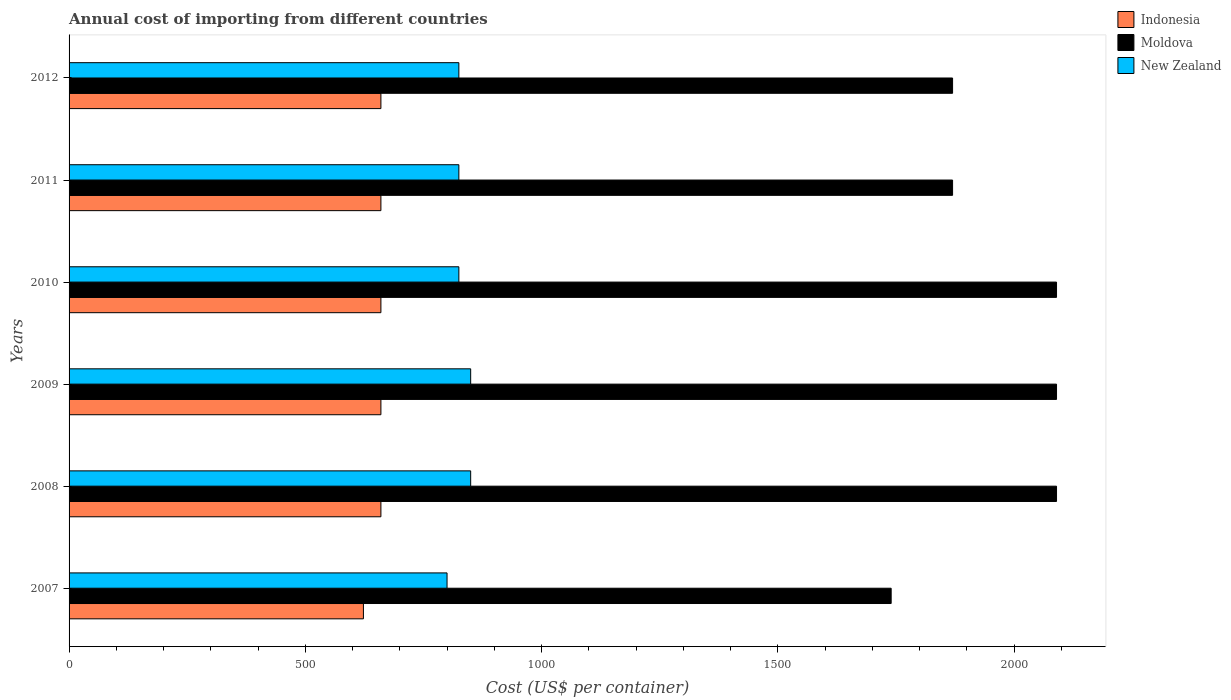How many different coloured bars are there?
Give a very brief answer. 3. How many bars are there on the 1st tick from the top?
Keep it short and to the point. 3. In how many cases, is the number of bars for a given year not equal to the number of legend labels?
Your answer should be compact. 0. What is the total annual cost of importing in New Zealand in 2007?
Offer a very short reply. 800. Across all years, what is the maximum total annual cost of importing in Moldova?
Your response must be concise. 2090. Across all years, what is the minimum total annual cost of importing in New Zealand?
Your answer should be very brief. 800. In which year was the total annual cost of importing in Moldova minimum?
Keep it short and to the point. 2007. What is the total total annual cost of importing in New Zealand in the graph?
Provide a short and direct response. 4975. What is the difference between the total annual cost of importing in New Zealand in 2008 and that in 2012?
Provide a short and direct response. 25. What is the difference between the total annual cost of importing in Indonesia in 2009 and the total annual cost of importing in Moldova in 2007?
Offer a terse response. -1080. What is the average total annual cost of importing in New Zealand per year?
Your answer should be compact. 829.17. In the year 2011, what is the difference between the total annual cost of importing in Indonesia and total annual cost of importing in New Zealand?
Provide a succinct answer. -165. What is the ratio of the total annual cost of importing in Moldova in 2010 to that in 2012?
Your answer should be compact. 1.12. What is the difference between the highest and the second highest total annual cost of importing in New Zealand?
Provide a succinct answer. 0. What is the difference between the highest and the lowest total annual cost of importing in New Zealand?
Provide a short and direct response. 50. Is the sum of the total annual cost of importing in New Zealand in 2007 and 2009 greater than the maximum total annual cost of importing in Indonesia across all years?
Keep it short and to the point. Yes. What does the 2nd bar from the top in 2010 represents?
Offer a very short reply. Moldova. What does the 3rd bar from the bottom in 2009 represents?
Offer a terse response. New Zealand. Is it the case that in every year, the sum of the total annual cost of importing in New Zealand and total annual cost of importing in Indonesia is greater than the total annual cost of importing in Moldova?
Provide a succinct answer. No. How many bars are there?
Your answer should be very brief. 18. What is the difference between two consecutive major ticks on the X-axis?
Keep it short and to the point. 500. Are the values on the major ticks of X-axis written in scientific E-notation?
Provide a succinct answer. No. Does the graph contain any zero values?
Offer a terse response. No. Where does the legend appear in the graph?
Provide a short and direct response. Top right. How are the legend labels stacked?
Offer a terse response. Vertical. What is the title of the graph?
Offer a very short reply. Annual cost of importing from different countries. What is the label or title of the X-axis?
Offer a terse response. Cost (US$ per container). What is the Cost (US$ per container) of Indonesia in 2007?
Your answer should be very brief. 623. What is the Cost (US$ per container) in Moldova in 2007?
Make the answer very short. 1740. What is the Cost (US$ per container) of New Zealand in 2007?
Your answer should be very brief. 800. What is the Cost (US$ per container) in Indonesia in 2008?
Your answer should be compact. 660. What is the Cost (US$ per container) in Moldova in 2008?
Offer a very short reply. 2090. What is the Cost (US$ per container) in New Zealand in 2008?
Make the answer very short. 850. What is the Cost (US$ per container) in Indonesia in 2009?
Ensure brevity in your answer.  660. What is the Cost (US$ per container) of Moldova in 2009?
Provide a succinct answer. 2090. What is the Cost (US$ per container) in New Zealand in 2009?
Ensure brevity in your answer.  850. What is the Cost (US$ per container) in Indonesia in 2010?
Give a very brief answer. 660. What is the Cost (US$ per container) of Moldova in 2010?
Keep it short and to the point. 2090. What is the Cost (US$ per container) in New Zealand in 2010?
Keep it short and to the point. 825. What is the Cost (US$ per container) of Indonesia in 2011?
Ensure brevity in your answer.  660. What is the Cost (US$ per container) of Moldova in 2011?
Give a very brief answer. 1870. What is the Cost (US$ per container) of New Zealand in 2011?
Offer a very short reply. 825. What is the Cost (US$ per container) in Indonesia in 2012?
Your response must be concise. 660. What is the Cost (US$ per container) of Moldova in 2012?
Your response must be concise. 1870. What is the Cost (US$ per container) in New Zealand in 2012?
Offer a very short reply. 825. Across all years, what is the maximum Cost (US$ per container) of Indonesia?
Offer a very short reply. 660. Across all years, what is the maximum Cost (US$ per container) of Moldova?
Make the answer very short. 2090. Across all years, what is the maximum Cost (US$ per container) of New Zealand?
Provide a short and direct response. 850. Across all years, what is the minimum Cost (US$ per container) of Indonesia?
Keep it short and to the point. 623. Across all years, what is the minimum Cost (US$ per container) of Moldova?
Provide a succinct answer. 1740. Across all years, what is the minimum Cost (US$ per container) in New Zealand?
Offer a very short reply. 800. What is the total Cost (US$ per container) in Indonesia in the graph?
Your answer should be compact. 3923. What is the total Cost (US$ per container) in Moldova in the graph?
Offer a very short reply. 1.18e+04. What is the total Cost (US$ per container) in New Zealand in the graph?
Your response must be concise. 4975. What is the difference between the Cost (US$ per container) in Indonesia in 2007 and that in 2008?
Offer a terse response. -37. What is the difference between the Cost (US$ per container) of Moldova in 2007 and that in 2008?
Keep it short and to the point. -350. What is the difference between the Cost (US$ per container) in New Zealand in 2007 and that in 2008?
Your answer should be very brief. -50. What is the difference between the Cost (US$ per container) in Indonesia in 2007 and that in 2009?
Give a very brief answer. -37. What is the difference between the Cost (US$ per container) of Moldova in 2007 and that in 2009?
Your response must be concise. -350. What is the difference between the Cost (US$ per container) of Indonesia in 2007 and that in 2010?
Keep it short and to the point. -37. What is the difference between the Cost (US$ per container) in Moldova in 2007 and that in 2010?
Your response must be concise. -350. What is the difference between the Cost (US$ per container) in Indonesia in 2007 and that in 2011?
Make the answer very short. -37. What is the difference between the Cost (US$ per container) of Moldova in 2007 and that in 2011?
Your answer should be very brief. -130. What is the difference between the Cost (US$ per container) in Indonesia in 2007 and that in 2012?
Offer a very short reply. -37. What is the difference between the Cost (US$ per container) of Moldova in 2007 and that in 2012?
Offer a very short reply. -130. What is the difference between the Cost (US$ per container) in New Zealand in 2007 and that in 2012?
Make the answer very short. -25. What is the difference between the Cost (US$ per container) in Moldova in 2008 and that in 2009?
Keep it short and to the point. 0. What is the difference between the Cost (US$ per container) in Indonesia in 2008 and that in 2010?
Make the answer very short. 0. What is the difference between the Cost (US$ per container) in Moldova in 2008 and that in 2010?
Give a very brief answer. 0. What is the difference between the Cost (US$ per container) in Moldova in 2008 and that in 2011?
Offer a terse response. 220. What is the difference between the Cost (US$ per container) of New Zealand in 2008 and that in 2011?
Give a very brief answer. 25. What is the difference between the Cost (US$ per container) in Moldova in 2008 and that in 2012?
Give a very brief answer. 220. What is the difference between the Cost (US$ per container) in New Zealand in 2008 and that in 2012?
Your answer should be compact. 25. What is the difference between the Cost (US$ per container) of Indonesia in 2009 and that in 2010?
Provide a short and direct response. 0. What is the difference between the Cost (US$ per container) of New Zealand in 2009 and that in 2010?
Make the answer very short. 25. What is the difference between the Cost (US$ per container) in Indonesia in 2009 and that in 2011?
Your answer should be very brief. 0. What is the difference between the Cost (US$ per container) in Moldova in 2009 and that in 2011?
Provide a short and direct response. 220. What is the difference between the Cost (US$ per container) in Indonesia in 2009 and that in 2012?
Keep it short and to the point. 0. What is the difference between the Cost (US$ per container) of Moldova in 2009 and that in 2012?
Make the answer very short. 220. What is the difference between the Cost (US$ per container) in Moldova in 2010 and that in 2011?
Offer a very short reply. 220. What is the difference between the Cost (US$ per container) of New Zealand in 2010 and that in 2011?
Your answer should be compact. 0. What is the difference between the Cost (US$ per container) in Moldova in 2010 and that in 2012?
Your response must be concise. 220. What is the difference between the Cost (US$ per container) of Moldova in 2011 and that in 2012?
Your response must be concise. 0. What is the difference between the Cost (US$ per container) of New Zealand in 2011 and that in 2012?
Provide a succinct answer. 0. What is the difference between the Cost (US$ per container) in Indonesia in 2007 and the Cost (US$ per container) in Moldova in 2008?
Offer a very short reply. -1467. What is the difference between the Cost (US$ per container) of Indonesia in 2007 and the Cost (US$ per container) of New Zealand in 2008?
Your answer should be very brief. -227. What is the difference between the Cost (US$ per container) in Moldova in 2007 and the Cost (US$ per container) in New Zealand in 2008?
Your answer should be compact. 890. What is the difference between the Cost (US$ per container) of Indonesia in 2007 and the Cost (US$ per container) of Moldova in 2009?
Your answer should be very brief. -1467. What is the difference between the Cost (US$ per container) in Indonesia in 2007 and the Cost (US$ per container) in New Zealand in 2009?
Your response must be concise. -227. What is the difference between the Cost (US$ per container) of Moldova in 2007 and the Cost (US$ per container) of New Zealand in 2009?
Offer a terse response. 890. What is the difference between the Cost (US$ per container) of Indonesia in 2007 and the Cost (US$ per container) of Moldova in 2010?
Keep it short and to the point. -1467. What is the difference between the Cost (US$ per container) of Indonesia in 2007 and the Cost (US$ per container) of New Zealand in 2010?
Provide a short and direct response. -202. What is the difference between the Cost (US$ per container) in Moldova in 2007 and the Cost (US$ per container) in New Zealand in 2010?
Provide a short and direct response. 915. What is the difference between the Cost (US$ per container) in Indonesia in 2007 and the Cost (US$ per container) in Moldova in 2011?
Give a very brief answer. -1247. What is the difference between the Cost (US$ per container) in Indonesia in 2007 and the Cost (US$ per container) in New Zealand in 2011?
Offer a very short reply. -202. What is the difference between the Cost (US$ per container) in Moldova in 2007 and the Cost (US$ per container) in New Zealand in 2011?
Offer a terse response. 915. What is the difference between the Cost (US$ per container) of Indonesia in 2007 and the Cost (US$ per container) of Moldova in 2012?
Make the answer very short. -1247. What is the difference between the Cost (US$ per container) in Indonesia in 2007 and the Cost (US$ per container) in New Zealand in 2012?
Your response must be concise. -202. What is the difference between the Cost (US$ per container) of Moldova in 2007 and the Cost (US$ per container) of New Zealand in 2012?
Provide a short and direct response. 915. What is the difference between the Cost (US$ per container) of Indonesia in 2008 and the Cost (US$ per container) of Moldova in 2009?
Provide a short and direct response. -1430. What is the difference between the Cost (US$ per container) of Indonesia in 2008 and the Cost (US$ per container) of New Zealand in 2009?
Your answer should be compact. -190. What is the difference between the Cost (US$ per container) of Moldova in 2008 and the Cost (US$ per container) of New Zealand in 2009?
Offer a very short reply. 1240. What is the difference between the Cost (US$ per container) of Indonesia in 2008 and the Cost (US$ per container) of Moldova in 2010?
Provide a succinct answer. -1430. What is the difference between the Cost (US$ per container) of Indonesia in 2008 and the Cost (US$ per container) of New Zealand in 2010?
Your answer should be very brief. -165. What is the difference between the Cost (US$ per container) in Moldova in 2008 and the Cost (US$ per container) in New Zealand in 2010?
Provide a short and direct response. 1265. What is the difference between the Cost (US$ per container) in Indonesia in 2008 and the Cost (US$ per container) in Moldova in 2011?
Give a very brief answer. -1210. What is the difference between the Cost (US$ per container) in Indonesia in 2008 and the Cost (US$ per container) in New Zealand in 2011?
Offer a terse response. -165. What is the difference between the Cost (US$ per container) in Moldova in 2008 and the Cost (US$ per container) in New Zealand in 2011?
Provide a succinct answer. 1265. What is the difference between the Cost (US$ per container) in Indonesia in 2008 and the Cost (US$ per container) in Moldova in 2012?
Ensure brevity in your answer.  -1210. What is the difference between the Cost (US$ per container) in Indonesia in 2008 and the Cost (US$ per container) in New Zealand in 2012?
Provide a succinct answer. -165. What is the difference between the Cost (US$ per container) of Moldova in 2008 and the Cost (US$ per container) of New Zealand in 2012?
Your answer should be compact. 1265. What is the difference between the Cost (US$ per container) of Indonesia in 2009 and the Cost (US$ per container) of Moldova in 2010?
Make the answer very short. -1430. What is the difference between the Cost (US$ per container) of Indonesia in 2009 and the Cost (US$ per container) of New Zealand in 2010?
Your answer should be compact. -165. What is the difference between the Cost (US$ per container) of Moldova in 2009 and the Cost (US$ per container) of New Zealand in 2010?
Provide a succinct answer. 1265. What is the difference between the Cost (US$ per container) in Indonesia in 2009 and the Cost (US$ per container) in Moldova in 2011?
Make the answer very short. -1210. What is the difference between the Cost (US$ per container) of Indonesia in 2009 and the Cost (US$ per container) of New Zealand in 2011?
Your response must be concise. -165. What is the difference between the Cost (US$ per container) of Moldova in 2009 and the Cost (US$ per container) of New Zealand in 2011?
Keep it short and to the point. 1265. What is the difference between the Cost (US$ per container) in Indonesia in 2009 and the Cost (US$ per container) in Moldova in 2012?
Ensure brevity in your answer.  -1210. What is the difference between the Cost (US$ per container) of Indonesia in 2009 and the Cost (US$ per container) of New Zealand in 2012?
Offer a very short reply. -165. What is the difference between the Cost (US$ per container) of Moldova in 2009 and the Cost (US$ per container) of New Zealand in 2012?
Provide a succinct answer. 1265. What is the difference between the Cost (US$ per container) in Indonesia in 2010 and the Cost (US$ per container) in Moldova in 2011?
Your response must be concise. -1210. What is the difference between the Cost (US$ per container) in Indonesia in 2010 and the Cost (US$ per container) in New Zealand in 2011?
Provide a short and direct response. -165. What is the difference between the Cost (US$ per container) of Moldova in 2010 and the Cost (US$ per container) of New Zealand in 2011?
Offer a terse response. 1265. What is the difference between the Cost (US$ per container) of Indonesia in 2010 and the Cost (US$ per container) of Moldova in 2012?
Make the answer very short. -1210. What is the difference between the Cost (US$ per container) of Indonesia in 2010 and the Cost (US$ per container) of New Zealand in 2012?
Offer a very short reply. -165. What is the difference between the Cost (US$ per container) in Moldova in 2010 and the Cost (US$ per container) in New Zealand in 2012?
Give a very brief answer. 1265. What is the difference between the Cost (US$ per container) of Indonesia in 2011 and the Cost (US$ per container) of Moldova in 2012?
Your answer should be compact. -1210. What is the difference between the Cost (US$ per container) in Indonesia in 2011 and the Cost (US$ per container) in New Zealand in 2012?
Ensure brevity in your answer.  -165. What is the difference between the Cost (US$ per container) in Moldova in 2011 and the Cost (US$ per container) in New Zealand in 2012?
Your answer should be very brief. 1045. What is the average Cost (US$ per container) in Indonesia per year?
Give a very brief answer. 653.83. What is the average Cost (US$ per container) of Moldova per year?
Offer a terse response. 1958.33. What is the average Cost (US$ per container) of New Zealand per year?
Make the answer very short. 829.17. In the year 2007, what is the difference between the Cost (US$ per container) in Indonesia and Cost (US$ per container) in Moldova?
Provide a succinct answer. -1117. In the year 2007, what is the difference between the Cost (US$ per container) of Indonesia and Cost (US$ per container) of New Zealand?
Your answer should be compact. -177. In the year 2007, what is the difference between the Cost (US$ per container) of Moldova and Cost (US$ per container) of New Zealand?
Your response must be concise. 940. In the year 2008, what is the difference between the Cost (US$ per container) in Indonesia and Cost (US$ per container) in Moldova?
Ensure brevity in your answer.  -1430. In the year 2008, what is the difference between the Cost (US$ per container) of Indonesia and Cost (US$ per container) of New Zealand?
Your answer should be compact. -190. In the year 2008, what is the difference between the Cost (US$ per container) in Moldova and Cost (US$ per container) in New Zealand?
Your answer should be very brief. 1240. In the year 2009, what is the difference between the Cost (US$ per container) in Indonesia and Cost (US$ per container) in Moldova?
Your response must be concise. -1430. In the year 2009, what is the difference between the Cost (US$ per container) in Indonesia and Cost (US$ per container) in New Zealand?
Keep it short and to the point. -190. In the year 2009, what is the difference between the Cost (US$ per container) in Moldova and Cost (US$ per container) in New Zealand?
Give a very brief answer. 1240. In the year 2010, what is the difference between the Cost (US$ per container) of Indonesia and Cost (US$ per container) of Moldova?
Give a very brief answer. -1430. In the year 2010, what is the difference between the Cost (US$ per container) in Indonesia and Cost (US$ per container) in New Zealand?
Your answer should be very brief. -165. In the year 2010, what is the difference between the Cost (US$ per container) of Moldova and Cost (US$ per container) of New Zealand?
Offer a terse response. 1265. In the year 2011, what is the difference between the Cost (US$ per container) of Indonesia and Cost (US$ per container) of Moldova?
Give a very brief answer. -1210. In the year 2011, what is the difference between the Cost (US$ per container) of Indonesia and Cost (US$ per container) of New Zealand?
Your answer should be compact. -165. In the year 2011, what is the difference between the Cost (US$ per container) of Moldova and Cost (US$ per container) of New Zealand?
Your response must be concise. 1045. In the year 2012, what is the difference between the Cost (US$ per container) of Indonesia and Cost (US$ per container) of Moldova?
Offer a very short reply. -1210. In the year 2012, what is the difference between the Cost (US$ per container) in Indonesia and Cost (US$ per container) in New Zealand?
Your answer should be compact. -165. In the year 2012, what is the difference between the Cost (US$ per container) in Moldova and Cost (US$ per container) in New Zealand?
Keep it short and to the point. 1045. What is the ratio of the Cost (US$ per container) of Indonesia in 2007 to that in 2008?
Provide a short and direct response. 0.94. What is the ratio of the Cost (US$ per container) in Moldova in 2007 to that in 2008?
Your answer should be very brief. 0.83. What is the ratio of the Cost (US$ per container) of New Zealand in 2007 to that in 2008?
Ensure brevity in your answer.  0.94. What is the ratio of the Cost (US$ per container) of Indonesia in 2007 to that in 2009?
Keep it short and to the point. 0.94. What is the ratio of the Cost (US$ per container) in Moldova in 2007 to that in 2009?
Offer a terse response. 0.83. What is the ratio of the Cost (US$ per container) in Indonesia in 2007 to that in 2010?
Give a very brief answer. 0.94. What is the ratio of the Cost (US$ per container) in Moldova in 2007 to that in 2010?
Your answer should be very brief. 0.83. What is the ratio of the Cost (US$ per container) in New Zealand in 2007 to that in 2010?
Provide a short and direct response. 0.97. What is the ratio of the Cost (US$ per container) in Indonesia in 2007 to that in 2011?
Ensure brevity in your answer.  0.94. What is the ratio of the Cost (US$ per container) of Moldova in 2007 to that in 2011?
Your answer should be very brief. 0.93. What is the ratio of the Cost (US$ per container) of New Zealand in 2007 to that in 2011?
Keep it short and to the point. 0.97. What is the ratio of the Cost (US$ per container) in Indonesia in 2007 to that in 2012?
Offer a terse response. 0.94. What is the ratio of the Cost (US$ per container) of Moldova in 2007 to that in 2012?
Keep it short and to the point. 0.93. What is the ratio of the Cost (US$ per container) of New Zealand in 2007 to that in 2012?
Your answer should be compact. 0.97. What is the ratio of the Cost (US$ per container) of Moldova in 2008 to that in 2009?
Your response must be concise. 1. What is the ratio of the Cost (US$ per container) of Indonesia in 2008 to that in 2010?
Offer a very short reply. 1. What is the ratio of the Cost (US$ per container) in New Zealand in 2008 to that in 2010?
Keep it short and to the point. 1.03. What is the ratio of the Cost (US$ per container) of Moldova in 2008 to that in 2011?
Your response must be concise. 1.12. What is the ratio of the Cost (US$ per container) of New Zealand in 2008 to that in 2011?
Keep it short and to the point. 1.03. What is the ratio of the Cost (US$ per container) of Moldova in 2008 to that in 2012?
Provide a succinct answer. 1.12. What is the ratio of the Cost (US$ per container) of New Zealand in 2008 to that in 2012?
Your answer should be very brief. 1.03. What is the ratio of the Cost (US$ per container) of Indonesia in 2009 to that in 2010?
Give a very brief answer. 1. What is the ratio of the Cost (US$ per container) in Moldova in 2009 to that in 2010?
Your response must be concise. 1. What is the ratio of the Cost (US$ per container) of New Zealand in 2009 to that in 2010?
Ensure brevity in your answer.  1.03. What is the ratio of the Cost (US$ per container) in Indonesia in 2009 to that in 2011?
Offer a very short reply. 1. What is the ratio of the Cost (US$ per container) in Moldova in 2009 to that in 2011?
Keep it short and to the point. 1.12. What is the ratio of the Cost (US$ per container) in New Zealand in 2009 to that in 2011?
Your response must be concise. 1.03. What is the ratio of the Cost (US$ per container) in Indonesia in 2009 to that in 2012?
Provide a succinct answer. 1. What is the ratio of the Cost (US$ per container) in Moldova in 2009 to that in 2012?
Offer a very short reply. 1.12. What is the ratio of the Cost (US$ per container) in New Zealand in 2009 to that in 2012?
Your answer should be very brief. 1.03. What is the ratio of the Cost (US$ per container) of Indonesia in 2010 to that in 2011?
Provide a succinct answer. 1. What is the ratio of the Cost (US$ per container) of Moldova in 2010 to that in 2011?
Your response must be concise. 1.12. What is the ratio of the Cost (US$ per container) in Moldova in 2010 to that in 2012?
Provide a short and direct response. 1.12. What is the ratio of the Cost (US$ per container) of Indonesia in 2011 to that in 2012?
Provide a short and direct response. 1. What is the ratio of the Cost (US$ per container) in New Zealand in 2011 to that in 2012?
Provide a succinct answer. 1. What is the difference between the highest and the second highest Cost (US$ per container) of Moldova?
Your answer should be very brief. 0. What is the difference between the highest and the second highest Cost (US$ per container) of New Zealand?
Your answer should be compact. 0. What is the difference between the highest and the lowest Cost (US$ per container) of Indonesia?
Ensure brevity in your answer.  37. What is the difference between the highest and the lowest Cost (US$ per container) in Moldova?
Your answer should be compact. 350. 